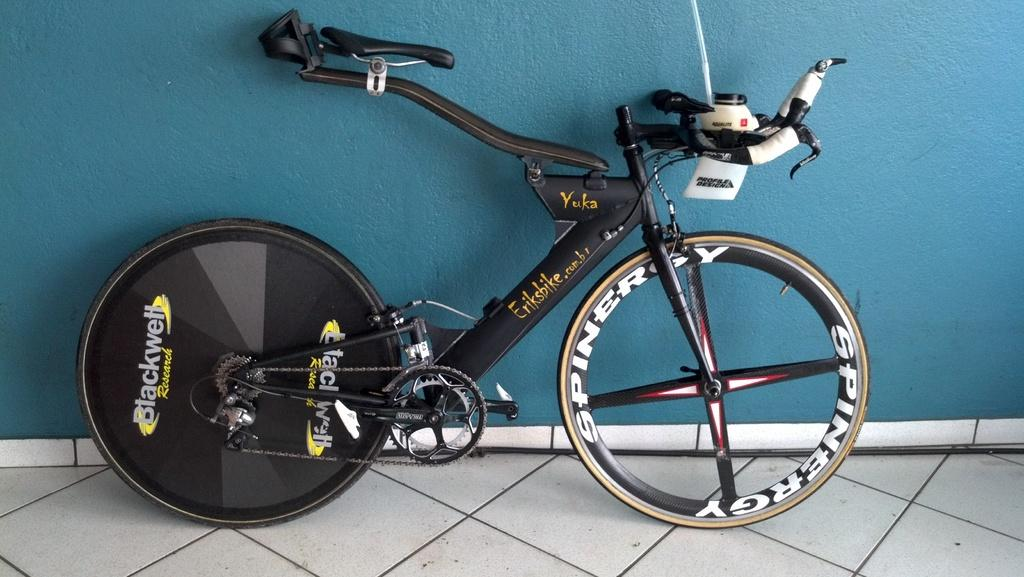What type of vehicle is in the image? There is a sports bicycle in the image. What type of flooring is visible in the image? There is marble flooring in the image. What is the background of the image? There is a wall in the image. What type of statement can be seen written on the wall in the image? There is no statement visible on the wall in the image. 